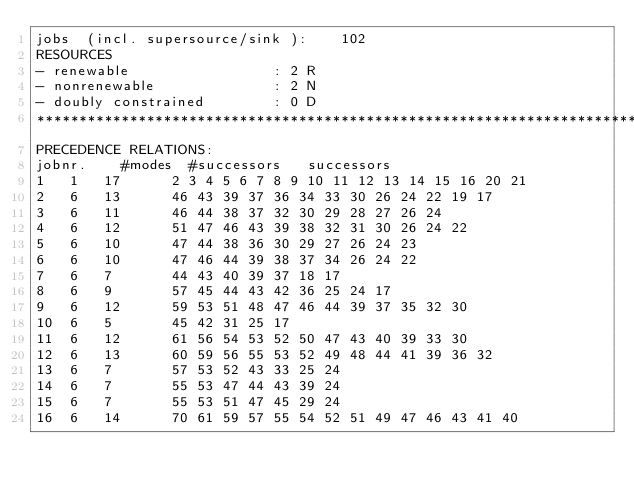<code> <loc_0><loc_0><loc_500><loc_500><_ObjectiveC_>jobs  (incl. supersource/sink ):	102
RESOURCES
- renewable                 : 2 R
- nonrenewable              : 2 N
- doubly constrained        : 0 D
************************************************************************
PRECEDENCE RELATIONS:
jobnr.    #modes  #successors   successors
1	1	17		2 3 4 5 6 7 8 9 10 11 12 13 14 15 16 20 21 
2	6	13		46 43 39 37 36 34 33 30 26 24 22 19 17 
3	6	11		46 44 38 37 32 30 29 28 27 26 24 
4	6	12		51 47 46 43 39 38 32 31 30 26 24 22 
5	6	10		47 44 38 36 30 29 27 26 24 23 
6	6	10		47 46 44 39 38 37 34 26 24 22 
7	6	7		44 43 40 39 37 18 17 
8	6	9		57 45 44 43 42 36 25 24 17 
9	6	12		59 53 51 48 47 46 44 39 37 35 32 30 
10	6	5		45 42 31 25 17 
11	6	12		61 56 54 53 52 50 47 43 40 39 33 30 
12	6	13		60 59 56 55 53 52 49 48 44 41 39 36 32 
13	6	7		57 53 52 43 33 25 24 
14	6	7		55 53 47 44 43 39 24 
15	6	7		55 53 51 47 45 29 24 
16	6	14		70 61 59 57 55 54 52 51 49 47 46 43 41 40 </code> 